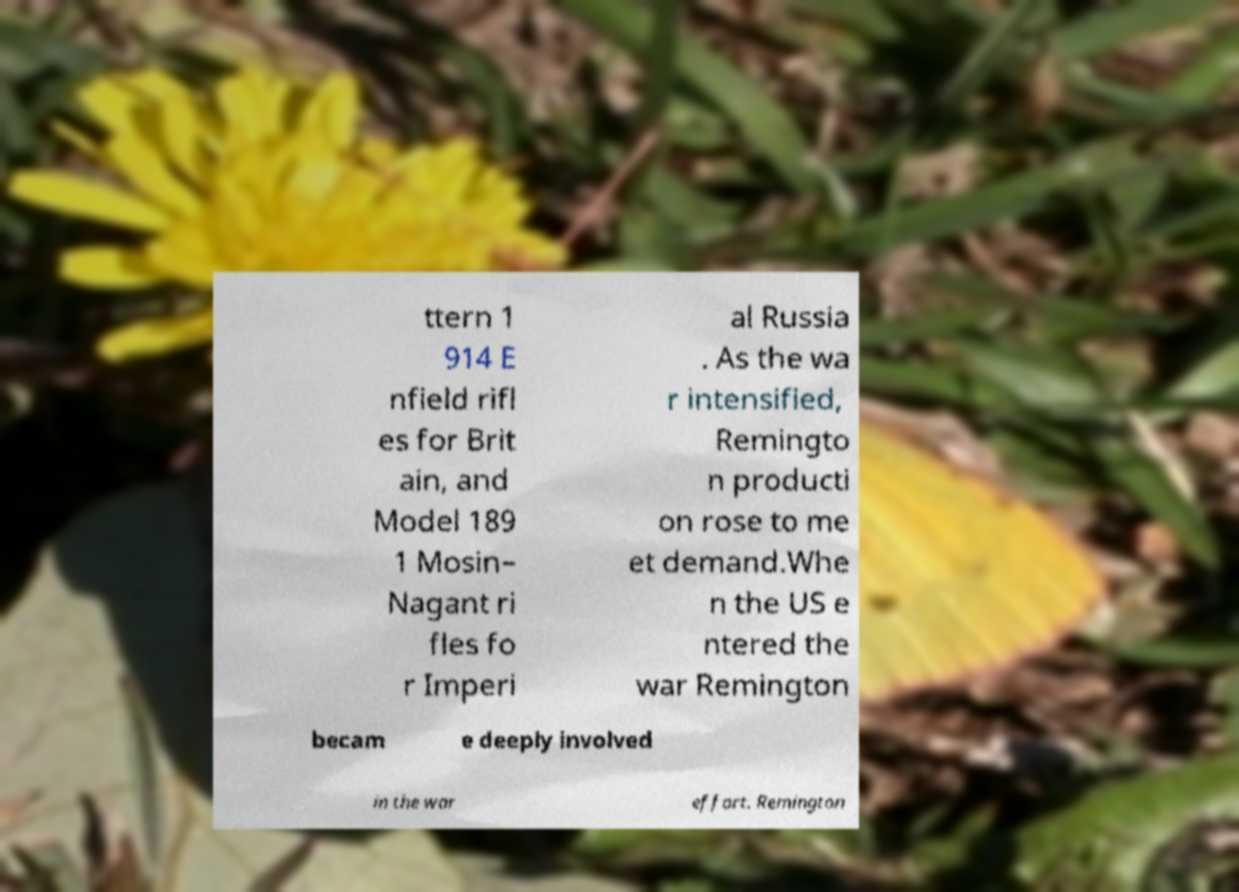Please identify and transcribe the text found in this image. ttern 1 914 E nfield rifl es for Brit ain, and Model 189 1 Mosin– Nagant ri fles fo r Imperi al Russia . As the wa r intensified, Remingto n producti on rose to me et demand.Whe n the US e ntered the war Remington becam e deeply involved in the war effort. Remington 